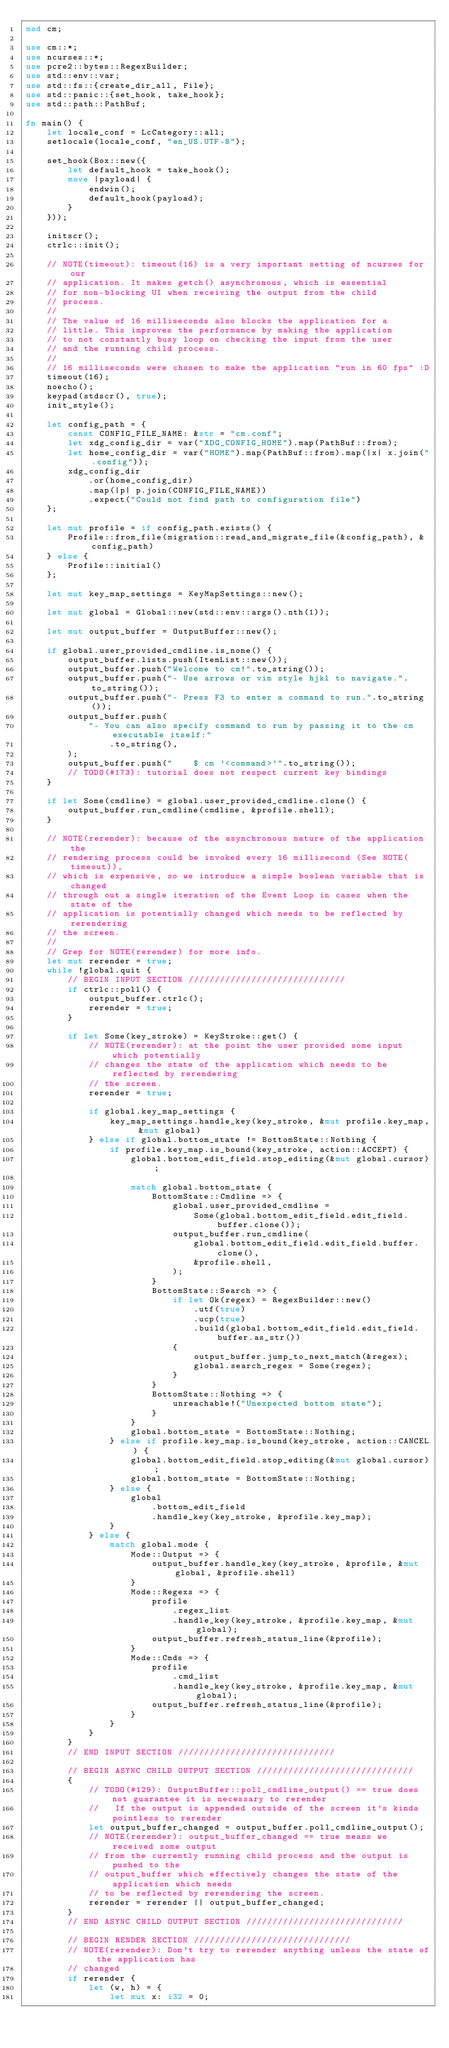<code> <loc_0><loc_0><loc_500><loc_500><_Rust_>mod cm;

use cm::*;
use ncurses::*;
use pcre2::bytes::RegexBuilder;
use std::env::var;
use std::fs::{create_dir_all, File};
use std::panic::{set_hook, take_hook};
use std::path::PathBuf;

fn main() {
    let locale_conf = LcCategory::all;
    setlocale(locale_conf, "en_US.UTF-8");

    set_hook(Box::new({
        let default_hook = take_hook();
        move |payload| {
            endwin();
            default_hook(payload);
        }
    }));

    initscr();
    ctrlc::init();

    // NOTE(timeout): timeout(16) is a very important setting of ncurses for our
    // application. It makes getch() asynchronous, which is essential
    // for non-blocking UI when receiving the output from the child
    // process.
    //
    // The value of 16 milliseconds also blocks the application for a
    // little. This improves the performance by making the application
    // to not constantly busy loop on checking the input from the user
    // and the running child process.
    //
    // 16 milliseconds were chosen to make the application "run in 60 fps" :D
    timeout(16);
    noecho();
    keypad(stdscr(), true);
    init_style();

    let config_path = {
        const CONFIG_FILE_NAME: &str = "cm.conf";
        let xdg_config_dir = var("XDG_CONFIG_HOME").map(PathBuf::from);
        let home_config_dir = var("HOME").map(PathBuf::from).map(|x| x.join(".config"));
        xdg_config_dir
            .or(home_config_dir)
            .map(|p| p.join(CONFIG_FILE_NAME))
            .expect("Could not find path to configuration file")
    };

    let mut profile = if config_path.exists() {
        Profile::from_file(migration::read_and_migrate_file(&config_path), &config_path)
    } else {
        Profile::initial()
    };

    let mut key_map_settings = KeyMapSettings::new();

    let mut global = Global::new(std::env::args().nth(1));

    let mut output_buffer = OutputBuffer::new();

    if global.user_provided_cmdline.is_none() {
        output_buffer.lists.push(ItemList::new());
        output_buffer.push("Welcome to cm!".to_string());
        output_buffer.push("- Use arrows or vim style hjkl to navigate.".to_string());
        output_buffer.push("- Press F3 to enter a command to run.".to_string());
        output_buffer.push(
            "- You can also specify command to run by passing it to the cm executable itself:"
                .to_string(),
        );
        output_buffer.push("    $ cm '<command>'".to_string());
        // TODO(#173): tutorial does not respect current key bindings
    }

    if let Some(cmdline) = global.user_provided_cmdline.clone() {
        output_buffer.run_cmdline(cmdline, &profile.shell);
    }

    // NOTE(rerender): because of the asynchronous nature of the application the
    // rendering process could be invoked every 16 millisecond (See NOTE(timeout)),
    // which is expensive, so we introduce a simple boolean variable that is changed
    // through out a single iteration of the Event Loop in cases when the state of the
    // application is potentially changed which needs to be reflected by rerendering
    // the screen.
    //
    // Grep for NOTE(rerender) for more info.
    let mut rerender = true;
    while !global.quit {
        // BEGIN INPUT SECTION //////////////////////////////
        if ctrlc::poll() {
            output_buffer.ctrlc();
            rerender = true;
        }

        if let Some(key_stroke) = KeyStroke::get() {
            // NOTE(rerender): at the point the user provided some input which potentially
            // changes the state of the application which needs to be reflected by rerendering
            // the screen.
            rerender = true;

            if global.key_map_settings {
                key_map_settings.handle_key(key_stroke, &mut profile.key_map, &mut global)
            } else if global.bottom_state != BottomState::Nothing {
                if profile.key_map.is_bound(key_stroke, action::ACCEPT) {
                    global.bottom_edit_field.stop_editing(&mut global.cursor);

                    match global.bottom_state {
                        BottomState::Cmdline => {
                            global.user_provided_cmdline =
                                Some(global.bottom_edit_field.edit_field.buffer.clone());
                            output_buffer.run_cmdline(
                                global.bottom_edit_field.edit_field.buffer.clone(),
                                &profile.shell,
                            );
                        }
                        BottomState::Search => {
                            if let Ok(regex) = RegexBuilder::new()
                                .utf(true)
                                .ucp(true)
                                .build(global.bottom_edit_field.edit_field.buffer.as_str())
                            {
                                output_buffer.jump_to_next_match(&regex);
                                global.search_regex = Some(regex);
                            }
                        }
                        BottomState::Nothing => {
                            unreachable!("Unexpected bottom state");
                        }
                    }
                    global.bottom_state = BottomState::Nothing;
                } else if profile.key_map.is_bound(key_stroke, action::CANCEL) {
                    global.bottom_edit_field.stop_editing(&mut global.cursor);
                    global.bottom_state = BottomState::Nothing;
                } else {
                    global
                        .bottom_edit_field
                        .handle_key(key_stroke, &profile.key_map);
                }
            } else {
                match global.mode {
                    Mode::Output => {
                        output_buffer.handle_key(key_stroke, &profile, &mut global, &profile.shell)
                    }
                    Mode::Regexs => {
                        profile
                            .regex_list
                            .handle_key(key_stroke, &profile.key_map, &mut global);
                        output_buffer.refresh_status_line(&profile);
                    }
                    Mode::Cmds => {
                        profile
                            .cmd_list
                            .handle_key(key_stroke, &profile.key_map, &mut global);
                        output_buffer.refresh_status_line(&profile);
                    }
                }
            }
        }
        // END INPUT SECTION //////////////////////////////

        // BEGIN ASYNC CHILD OUTPUT SECTION //////////////////////////////
        {
            // TODO(#129): OutputBuffer::poll_cmdline_output() == true does not guarantee it is necessary to rerender
            //   If the output is appended outside of the screen it's kinda pointless to rerender
            let output_buffer_changed = output_buffer.poll_cmdline_output();
            // NOTE(rerender): output_buffer_changed == true means we received some output
            // from the currently running child process and the output is pushed to the
            // output_buffer which effectively changes the state of the application which needs
            // to be reflected by rerendering the screen.
            rerender = rerender || output_buffer_changed;
        }
        // END ASYNC CHILD OUTPUT SECTION //////////////////////////////

        // BEGIN RENDER SECTION //////////////////////////////
        // NOTE(rerender): Don't try to rerender anything unless the state of the application has
        // changed
        if rerender {
            let (w, h) = {
                let mut x: i32 = 0;</code> 